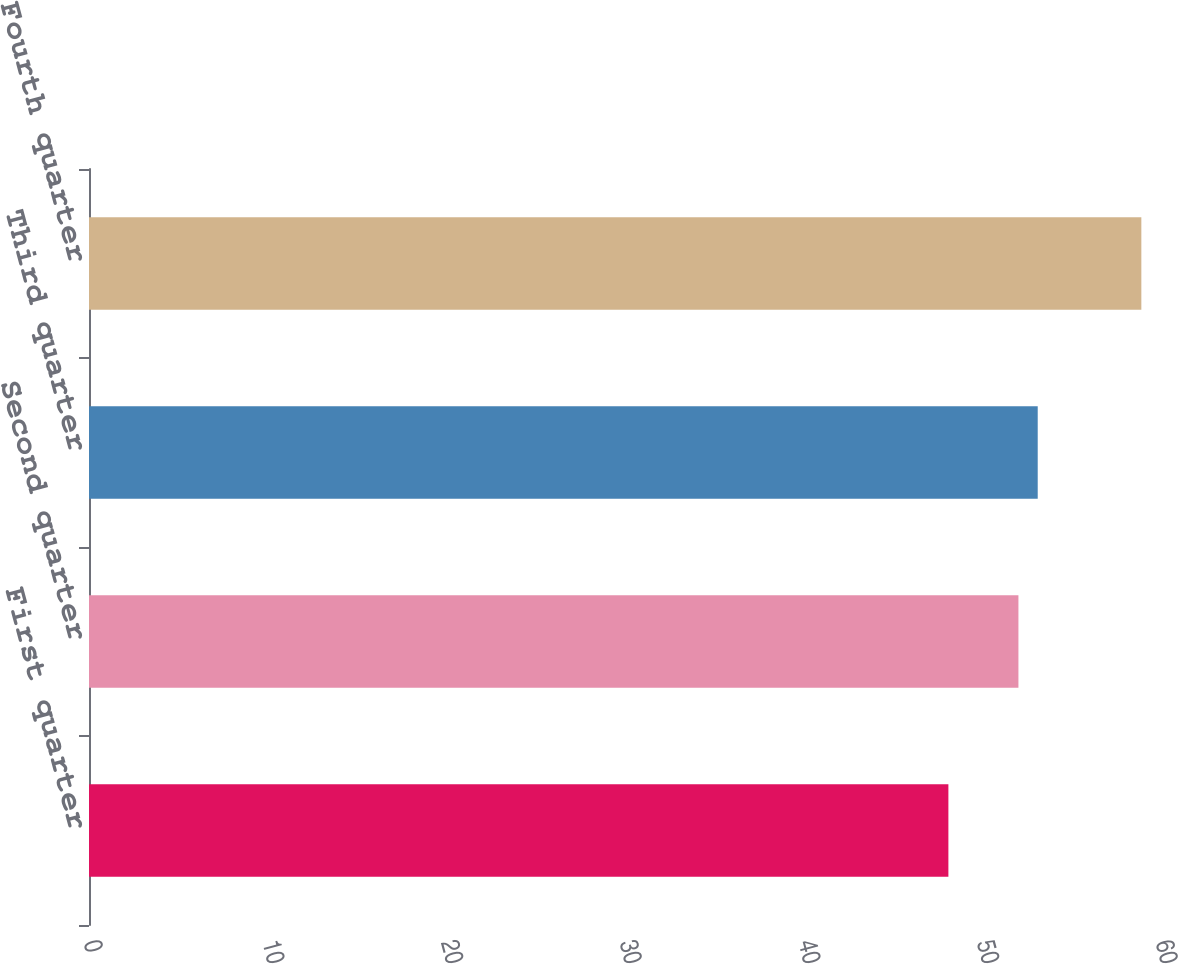Convert chart to OTSL. <chart><loc_0><loc_0><loc_500><loc_500><bar_chart><fcel>First quarter<fcel>Second quarter<fcel>Third quarter<fcel>Fourth quarter<nl><fcel>48.1<fcel>52.02<fcel>53.1<fcel>58.9<nl></chart> 